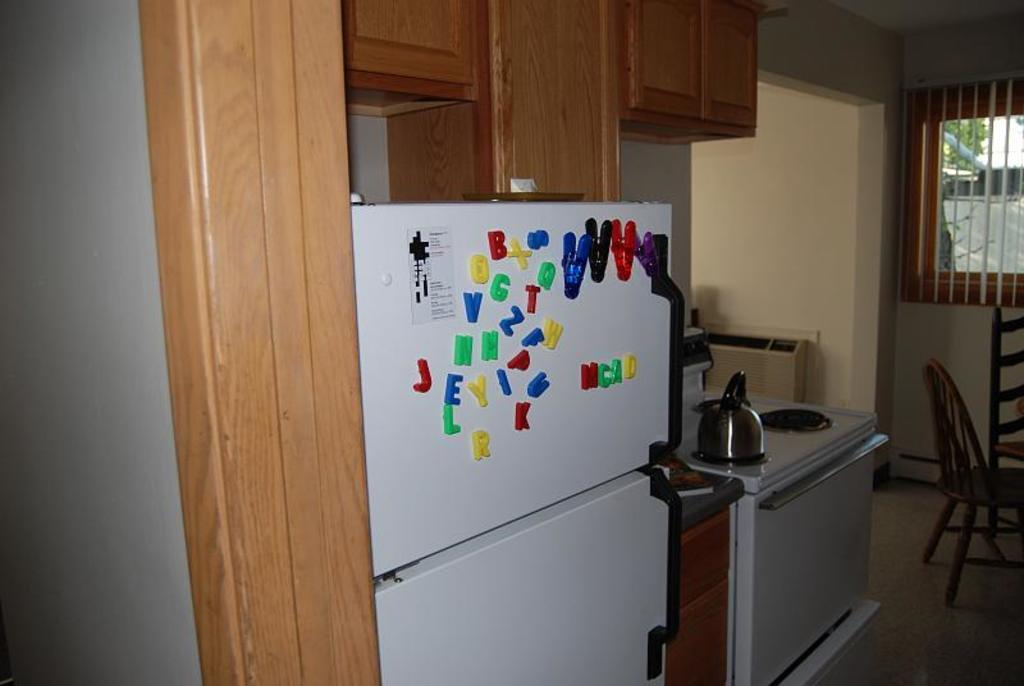<image>
Summarize the visual content of the image. A refrigerator with letter magnets MCAD placed together. 